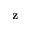Convert formula to latex. <formula><loc_0><loc_0><loc_500><loc_500>z</formula> 